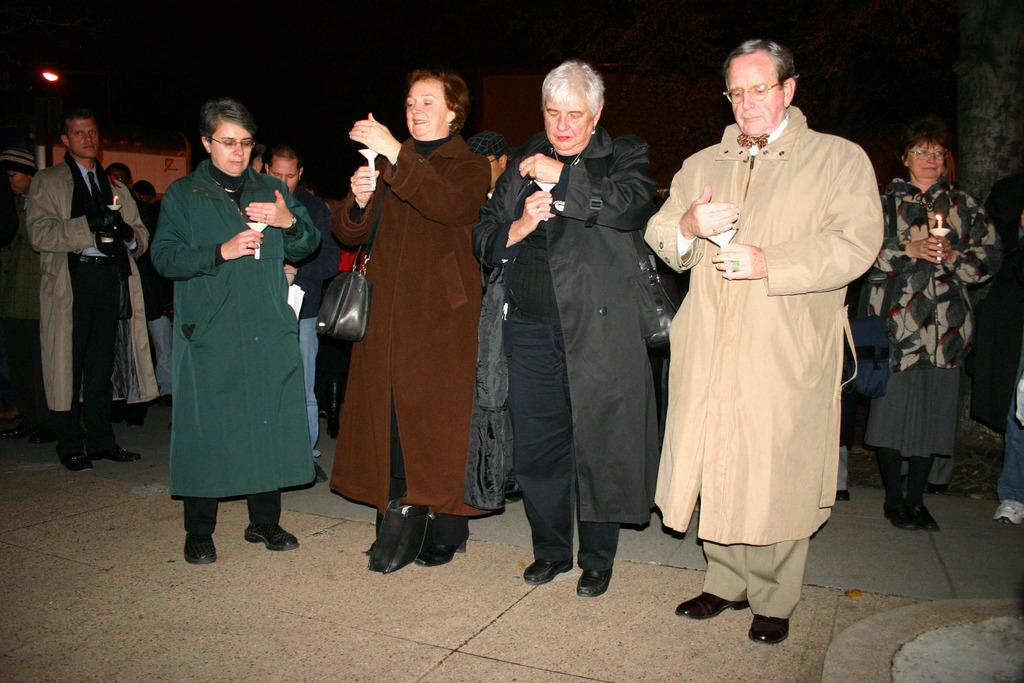How many people are in the image? There is a group of people in the image, but the exact number is not specified. What are the people holding in their hands? The people are holding candles in their hands. What can be seen in the background of the image? There is a wall visible in the background of the image. What rule is being enforced by the people holding screws in the image? A: There are no screws present in the image, and the people are holding candles, not screws. 